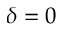Convert formula to latex. <formula><loc_0><loc_0><loc_500><loc_500>\delta = 0</formula> 